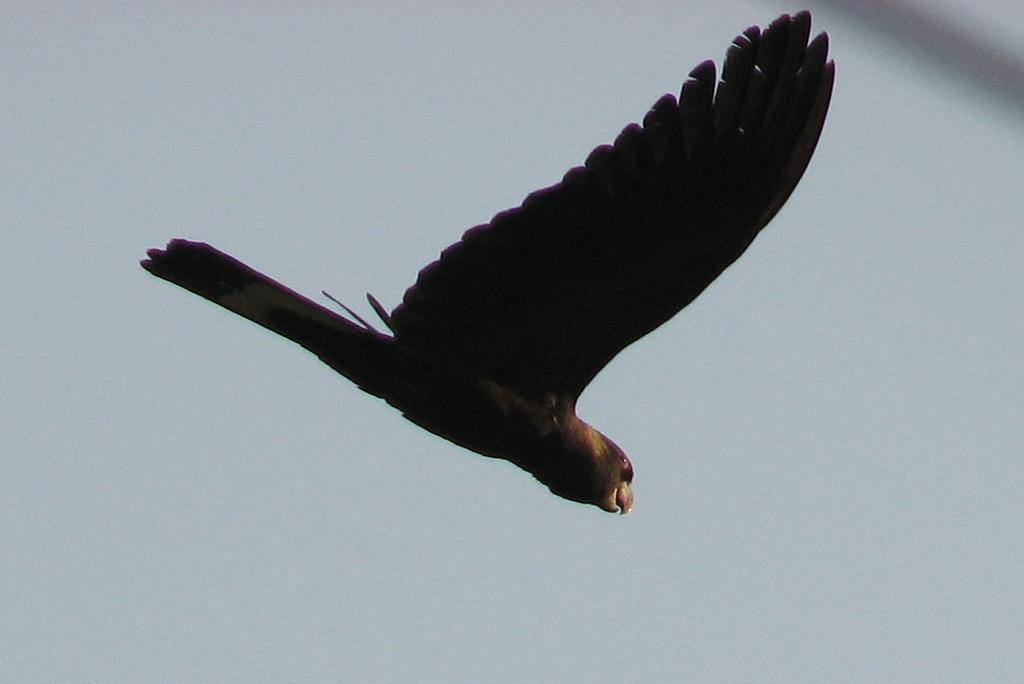What type of animal can be seen in the image? There is a bird in the image. What is the bird doing in the image? The bird is flying in the sky. What color are the bird's wings? The bird has black wings. What color are the bird's feathers? The bird has black feathers. What is the condition of the sky in the image? The sky is clear in the image. What type of creature is using the camera to capture the bird's desire in the image? There is no creature or camera present in the image, and the bird's desires cannot be determined from the image. 